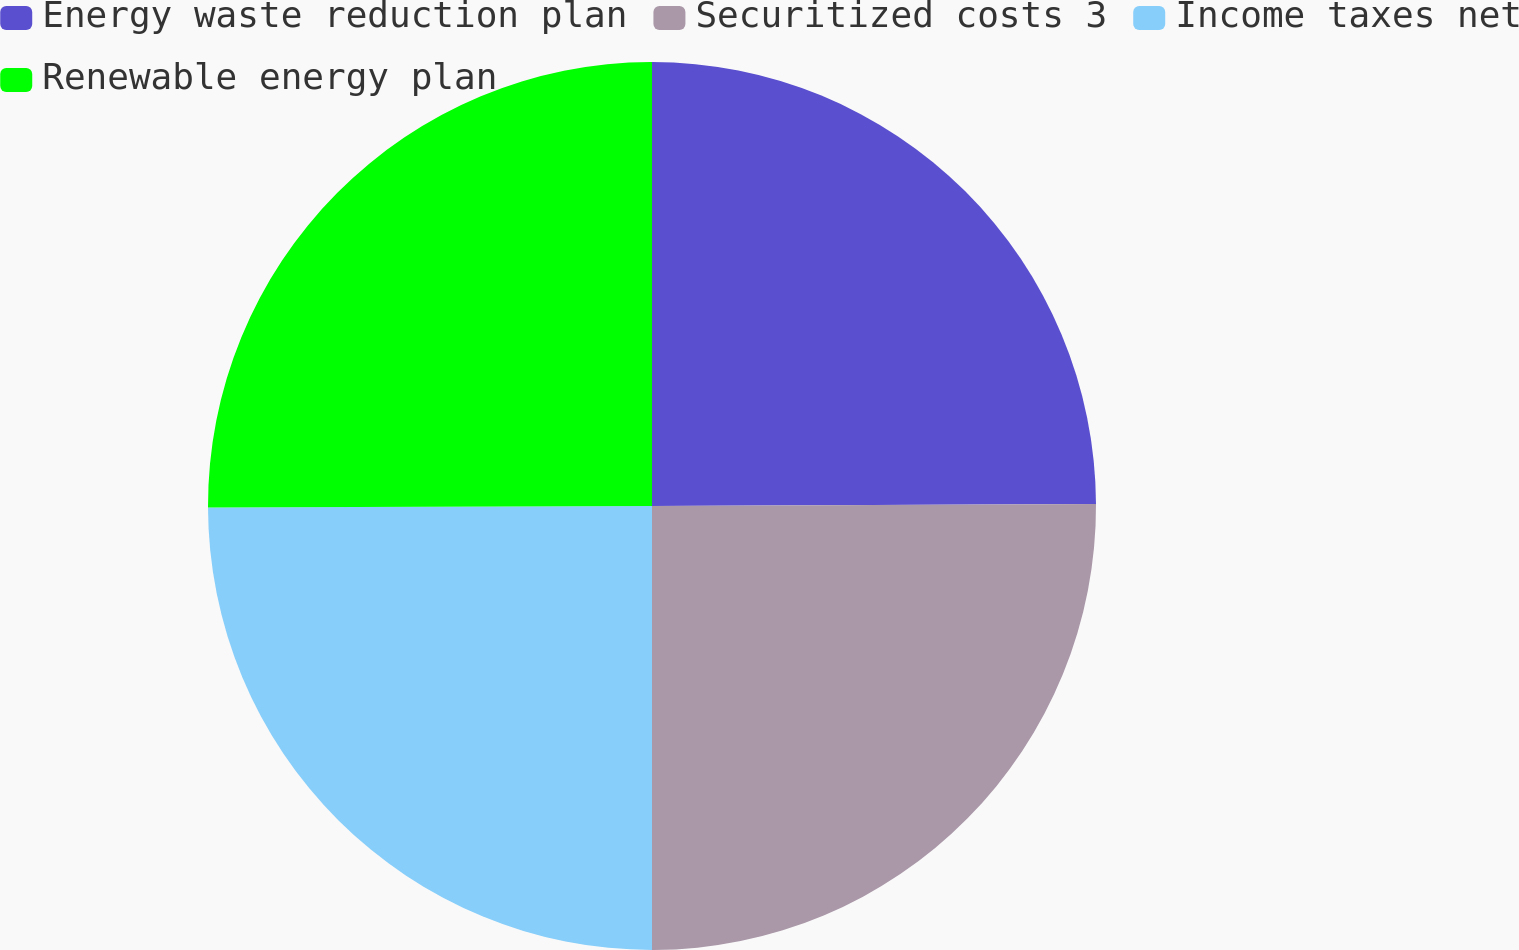Convert chart to OTSL. <chart><loc_0><loc_0><loc_500><loc_500><pie_chart><fcel>Energy waste reduction plan<fcel>Securitized costs 3<fcel>Income taxes net<fcel>Renewable energy plan<nl><fcel>24.93%<fcel>25.07%<fcel>24.95%<fcel>25.05%<nl></chart> 